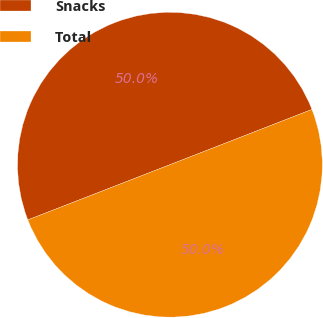<chart> <loc_0><loc_0><loc_500><loc_500><pie_chart><fcel>Snacks<fcel>Total<nl><fcel>49.99%<fcel>50.01%<nl></chart> 